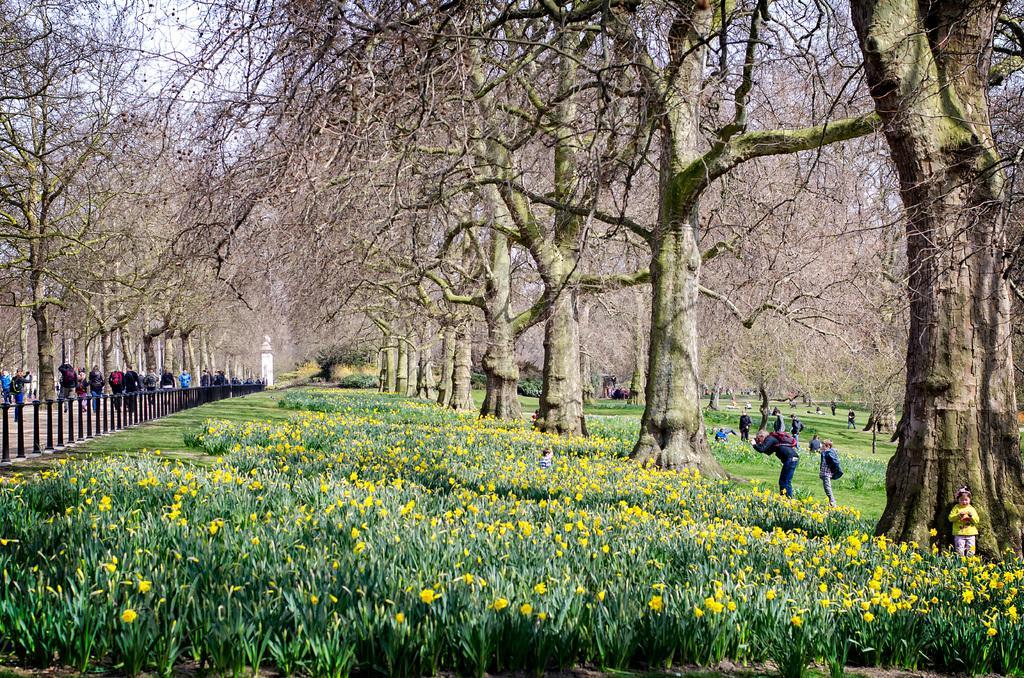Could you give a brief overview of what you see in this image? In this picture we can see some plants and flowers at the bottom, on the right side and left side there are trees and some people, on the left side we can see railing, there is the sky at the top of the picture. 